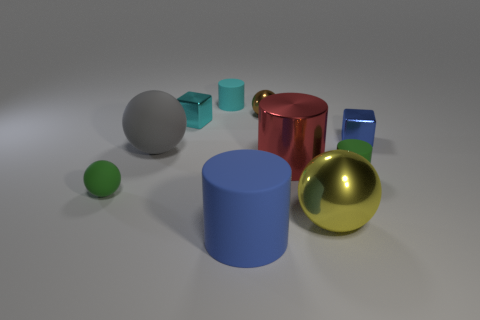What could the arrangement of these objects represent or be used for? The arrangement of these objects might be part of a visual composition exercise, perhaps for a study in 3D rendering, lighting, and shadow, or color theory, given the variety of hues and shapes. It's also possible that it's a simple spatial arrangement to study the interactions between different geometric forms and the effects of perspective. The way they are spread out could also mimic a relaxed, casual meeting of different elements, each one with its unique character and presence. 